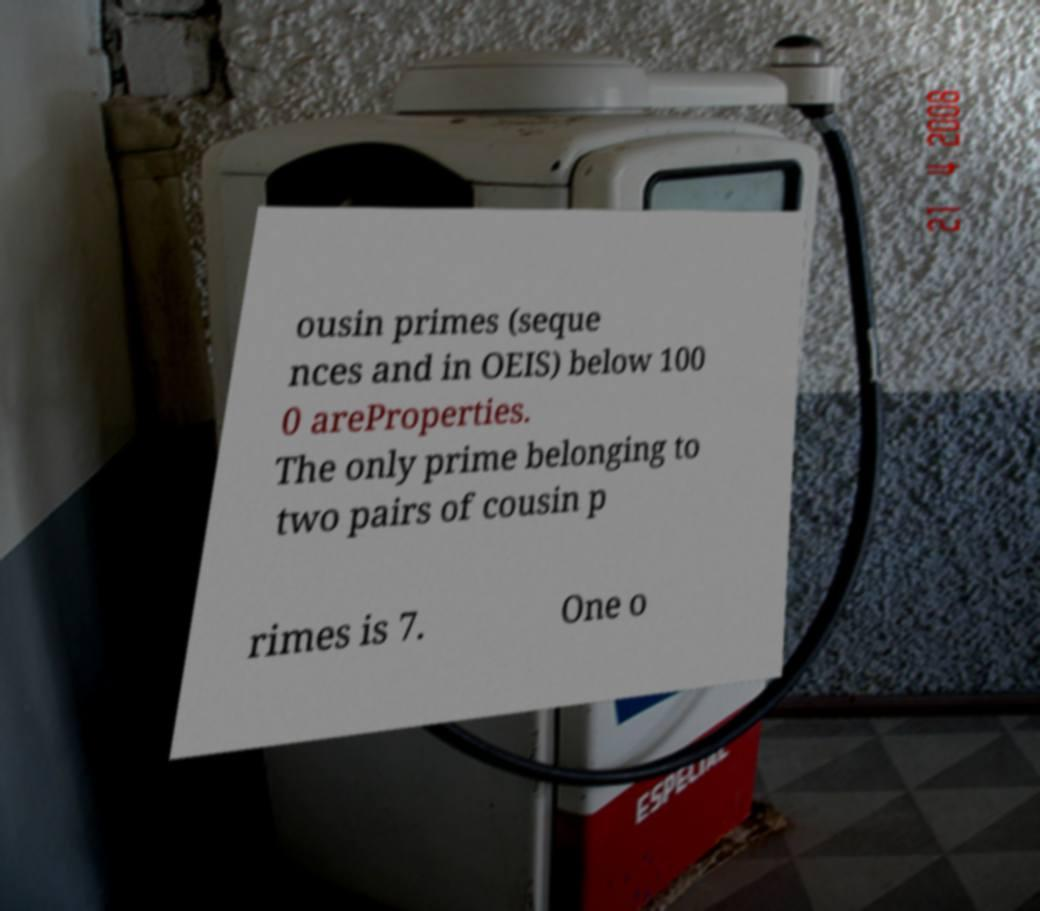What messages or text are displayed in this image? I need them in a readable, typed format. ousin primes (seque nces and in OEIS) below 100 0 areProperties. The only prime belonging to two pairs of cousin p rimes is 7. One o 